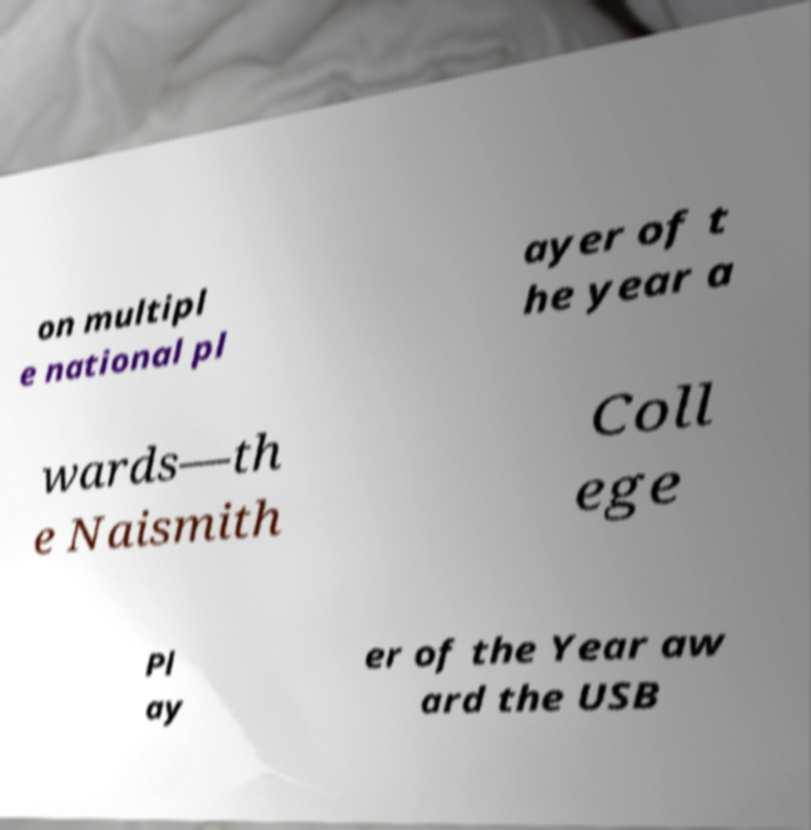Please read and relay the text visible in this image. What does it say? on multipl e national pl ayer of t he year a wards—th e Naismith Coll ege Pl ay er of the Year aw ard the USB 